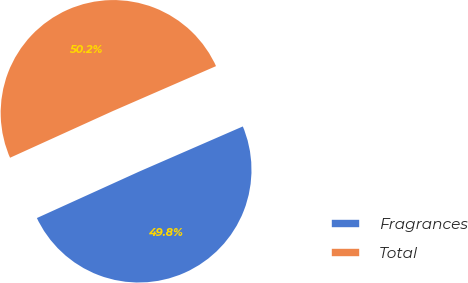Convert chart. <chart><loc_0><loc_0><loc_500><loc_500><pie_chart><fcel>Fragrances<fcel>Total<nl><fcel>49.75%<fcel>50.25%<nl></chart> 